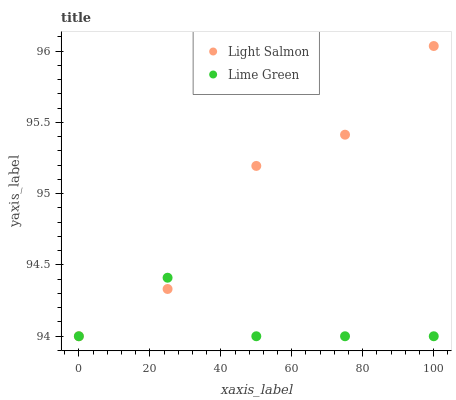Does Lime Green have the minimum area under the curve?
Answer yes or no. Yes. Does Light Salmon have the maximum area under the curve?
Answer yes or no. Yes. Does Lime Green have the maximum area under the curve?
Answer yes or no. No. Is Lime Green the smoothest?
Answer yes or no. Yes. Is Light Salmon the roughest?
Answer yes or no. Yes. Is Lime Green the roughest?
Answer yes or no. No. Does Light Salmon have the lowest value?
Answer yes or no. Yes. Does Light Salmon have the highest value?
Answer yes or no. Yes. Does Lime Green have the highest value?
Answer yes or no. No. Does Light Salmon intersect Lime Green?
Answer yes or no. Yes. Is Light Salmon less than Lime Green?
Answer yes or no. No. Is Light Salmon greater than Lime Green?
Answer yes or no. No. 